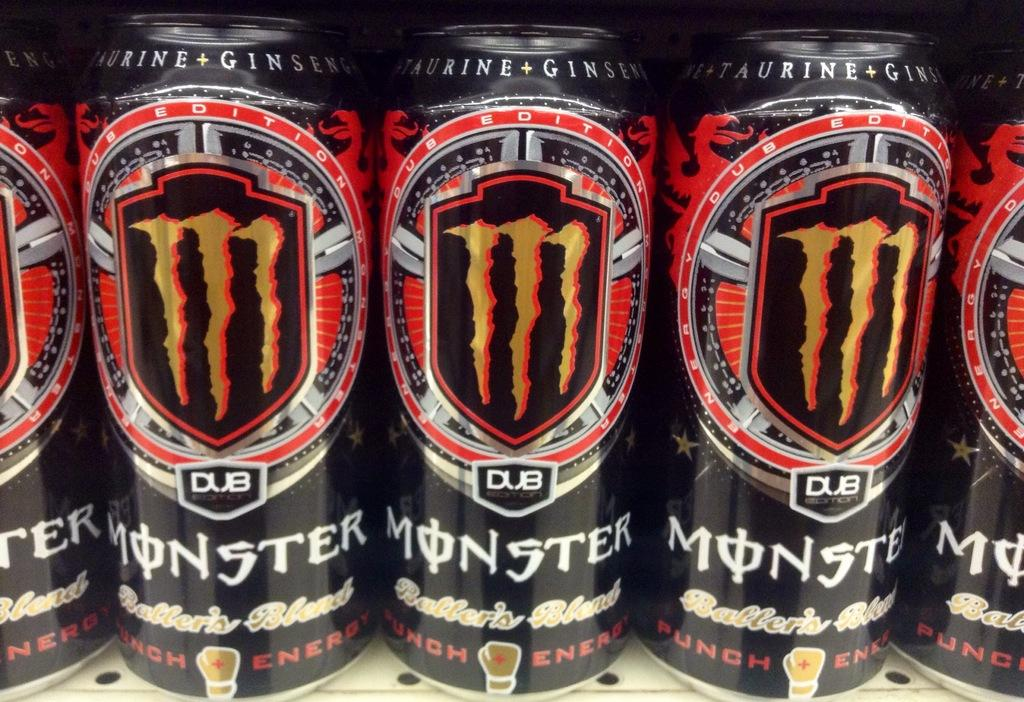Provide a one-sentence caption for the provided image. Several cans of Monster energy are lined up in a row. 